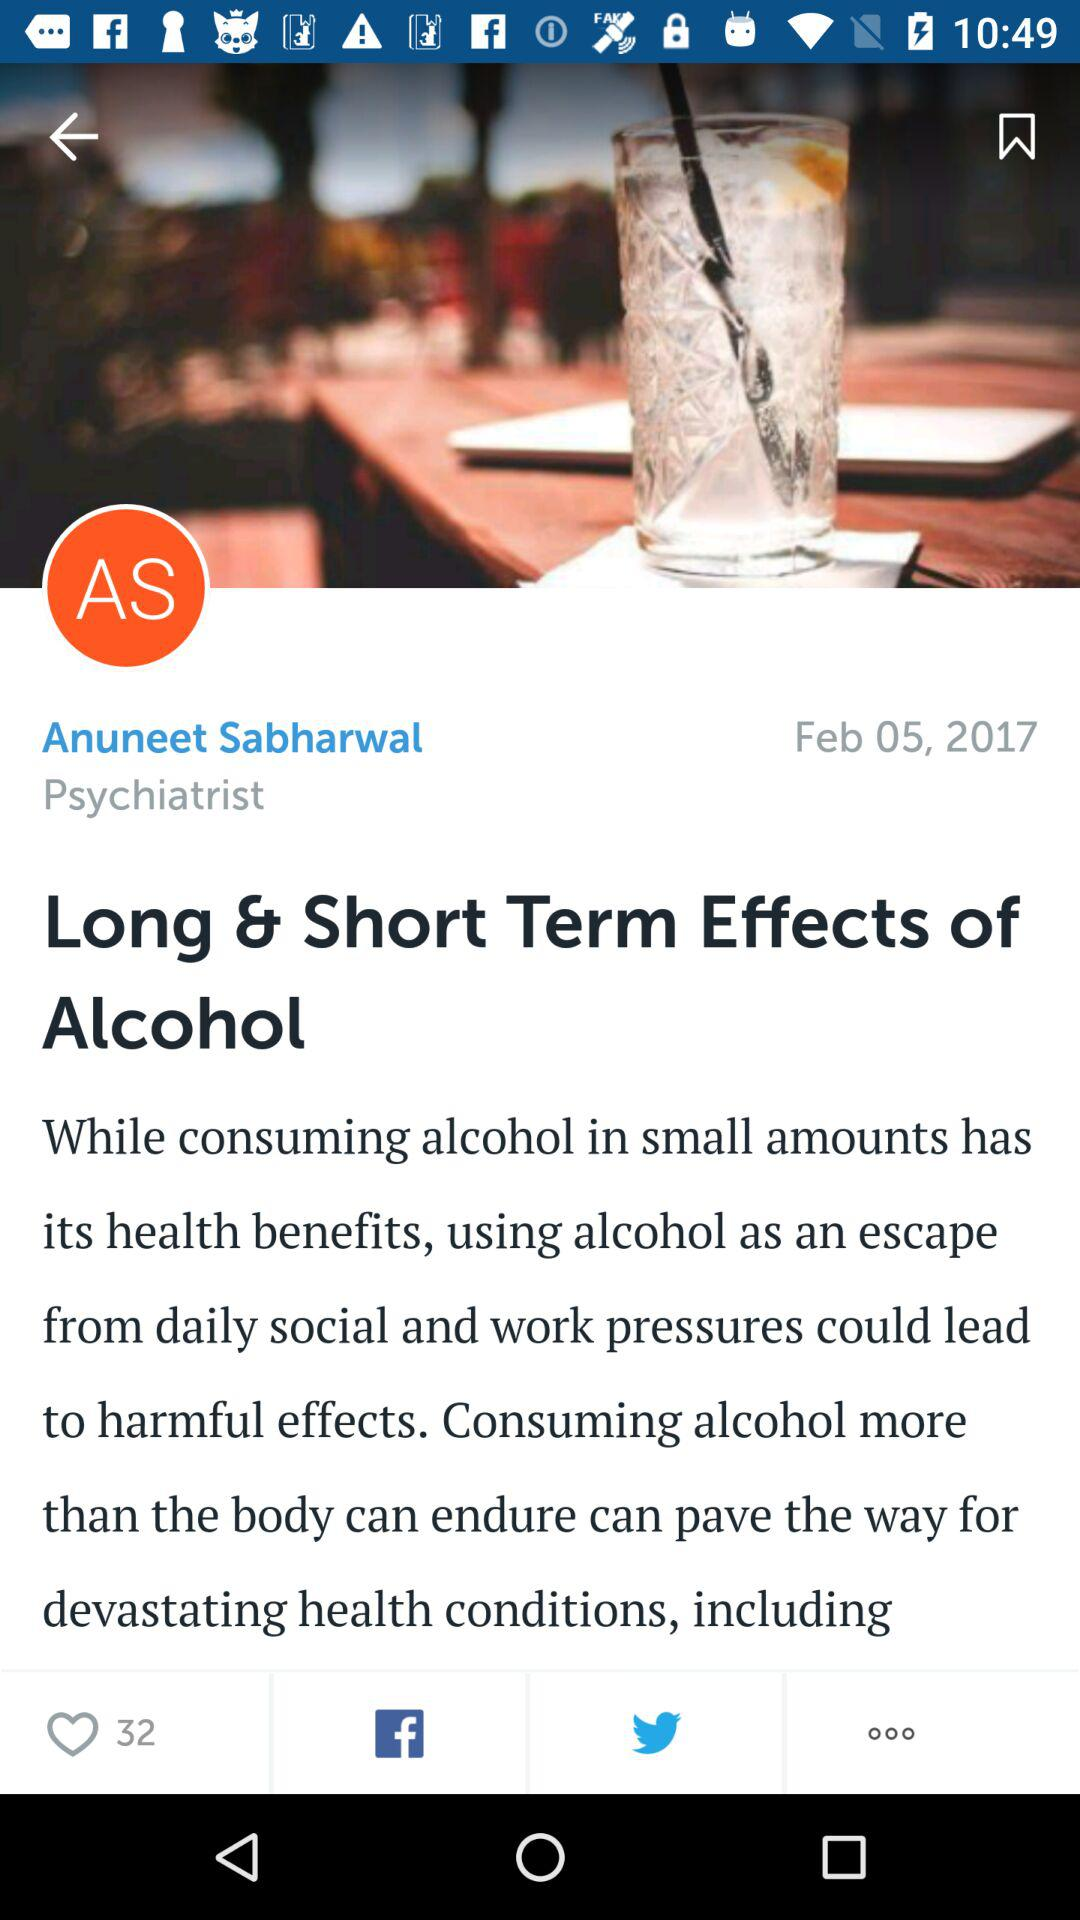What is the name of the application?
When the provided information is insufficient, respond with <no answer>. <no answer> 